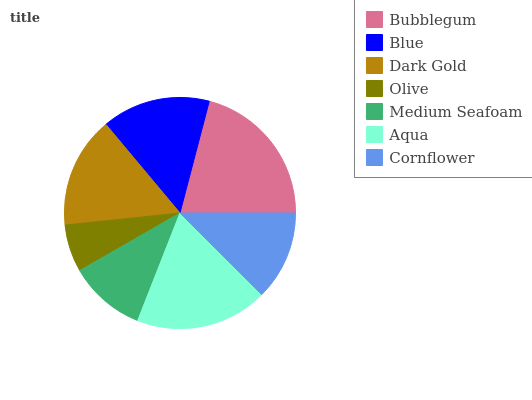Is Olive the minimum?
Answer yes or no. Yes. Is Bubblegum the maximum?
Answer yes or no. Yes. Is Blue the minimum?
Answer yes or no. No. Is Blue the maximum?
Answer yes or no. No. Is Bubblegum greater than Blue?
Answer yes or no. Yes. Is Blue less than Bubblegum?
Answer yes or no. Yes. Is Blue greater than Bubblegum?
Answer yes or no. No. Is Bubblegum less than Blue?
Answer yes or no. No. Is Blue the high median?
Answer yes or no. Yes. Is Blue the low median?
Answer yes or no. Yes. Is Bubblegum the high median?
Answer yes or no. No. Is Olive the low median?
Answer yes or no. No. 